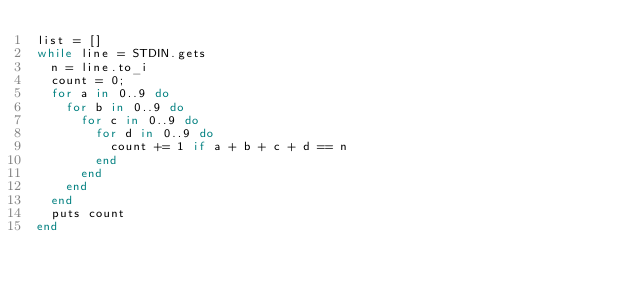<code> <loc_0><loc_0><loc_500><loc_500><_Ruby_>list = []
while line = STDIN.gets
  n = line.to_i
  count = 0;
  for a in 0..9 do
    for b in 0..9 do
      for c in 0..9 do
        for d in 0..9 do
          count += 1 if a + b + c + d == n
        end
      end
    end
  end
  puts count
end</code> 